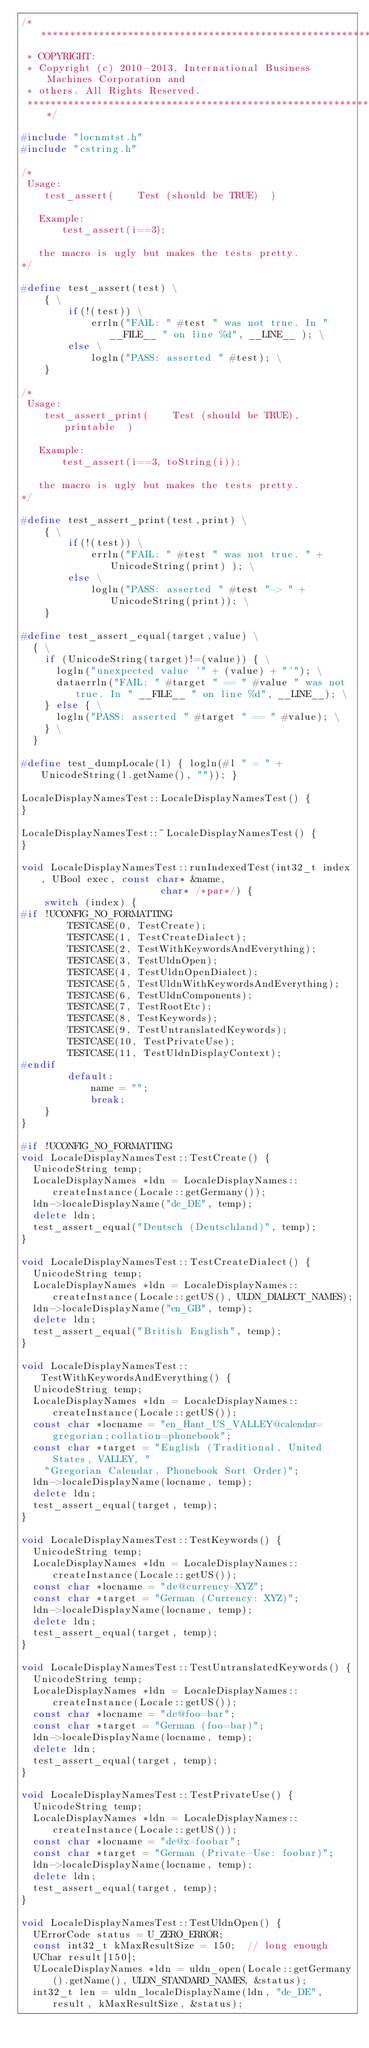Convert code to text. <code><loc_0><loc_0><loc_500><loc_500><_C++_>/*********************************************************************
 * COPYRIGHT:
 * Copyright (c) 2010-2013, International Business Machines Corporation and
 * others. All Rights Reserved.
 *********************************************************************/

#include "locnmtst.h"
#include "cstring.h"

/*
 Usage:
    test_assert(    Test (should be TRUE)  )

   Example:
       test_assert(i==3);

   the macro is ugly but makes the tests pretty.
*/

#define test_assert(test) \
    { \
        if(!(test)) \
            errln("FAIL: " #test " was not true. In " __FILE__ " on line %d", __LINE__ ); \
        else \
            logln("PASS: asserted " #test); \
    }

/*
 Usage:
    test_assert_print(    Test (should be TRUE),  printable  )

   Example:
       test_assert(i==3, toString(i));

   the macro is ugly but makes the tests pretty.
*/

#define test_assert_print(test,print) \
    { \
        if(!(test)) \
            errln("FAIL: " #test " was not true. " + UnicodeString(print) ); \
        else \
            logln("PASS: asserted " #test "-> " + UnicodeString(print)); \
    }

#define test_assert_equal(target,value) \
  { \
    if (UnicodeString(target)!=(value)) { \
      logln("unexpected value '" + (value) + "'"); \
      dataerrln("FAIL: " #target " == " #value " was not true. In " __FILE__ " on line %d", __LINE__); \
    } else { \
      logln("PASS: asserted " #target " == " #value); \
    } \
  }

#define test_dumpLocale(l) { logln(#l " = " + UnicodeString(l.getName(), "")); }

LocaleDisplayNamesTest::LocaleDisplayNamesTest() {
}

LocaleDisplayNamesTest::~LocaleDisplayNamesTest() {
}

void LocaleDisplayNamesTest::runIndexedTest(int32_t index, UBool exec, const char* &name, 
                        char* /*par*/) {
    switch (index) {
#if !UCONFIG_NO_FORMATTING
        TESTCASE(0, TestCreate);
        TESTCASE(1, TestCreateDialect);
        TESTCASE(2, TestWithKeywordsAndEverything);
        TESTCASE(3, TestUldnOpen);
        TESTCASE(4, TestUldnOpenDialect);
        TESTCASE(5, TestUldnWithKeywordsAndEverything);
        TESTCASE(6, TestUldnComponents);
        TESTCASE(7, TestRootEtc);
        TESTCASE(8, TestKeywords);
        TESTCASE(9, TestUntranslatedKeywords);
        TESTCASE(10, TestPrivateUse);
        TESTCASE(11, TestUldnDisplayContext);
#endif
        default:
            name = "";
            break;
    }
}

#if !UCONFIG_NO_FORMATTING
void LocaleDisplayNamesTest::TestCreate() {
  UnicodeString temp;
  LocaleDisplayNames *ldn = LocaleDisplayNames::createInstance(Locale::getGermany());
  ldn->localeDisplayName("de_DE", temp);
  delete ldn;
  test_assert_equal("Deutsch (Deutschland)", temp);
}

void LocaleDisplayNamesTest::TestCreateDialect() {
  UnicodeString temp;
  LocaleDisplayNames *ldn = LocaleDisplayNames::createInstance(Locale::getUS(), ULDN_DIALECT_NAMES);
  ldn->localeDisplayName("en_GB", temp);
  delete ldn;
  test_assert_equal("British English", temp);
}

void LocaleDisplayNamesTest::TestWithKeywordsAndEverything() {
  UnicodeString temp;
  LocaleDisplayNames *ldn = LocaleDisplayNames::createInstance(Locale::getUS());
  const char *locname = "en_Hant_US_VALLEY@calendar=gregorian;collation=phonebook";
  const char *target = "English (Traditional, United States, VALLEY, "
    "Gregorian Calendar, Phonebook Sort Order)";
  ldn->localeDisplayName(locname, temp);
  delete ldn;
  test_assert_equal(target, temp);
}

void LocaleDisplayNamesTest::TestKeywords() {
  UnicodeString temp;
  LocaleDisplayNames *ldn = LocaleDisplayNames::createInstance(Locale::getUS());
  const char *locname = "de@currency=XYZ";
  const char *target = "German (Currency: XYZ)";
  ldn->localeDisplayName(locname, temp);
  delete ldn;
  test_assert_equal(target, temp);
}

void LocaleDisplayNamesTest::TestUntranslatedKeywords() {
  UnicodeString temp;
  LocaleDisplayNames *ldn = LocaleDisplayNames::createInstance(Locale::getUS());
  const char *locname = "de@foo=bar";
  const char *target = "German (foo=bar)";
  ldn->localeDisplayName(locname, temp);
  delete ldn;
  test_assert_equal(target, temp);
}

void LocaleDisplayNamesTest::TestPrivateUse() {
  UnicodeString temp;
  LocaleDisplayNames *ldn = LocaleDisplayNames::createInstance(Locale::getUS());
  const char *locname = "de@x=foobar";
  const char *target = "German (Private-Use: foobar)";
  ldn->localeDisplayName(locname, temp);
  delete ldn;
  test_assert_equal(target, temp);
}

void LocaleDisplayNamesTest::TestUldnOpen() {
  UErrorCode status = U_ZERO_ERROR;
  const int32_t kMaxResultSize = 150;  // long enough
  UChar result[150];
  ULocaleDisplayNames *ldn = uldn_open(Locale::getGermany().getName(), ULDN_STANDARD_NAMES, &status);
  int32_t len = uldn_localeDisplayName(ldn, "de_DE", result, kMaxResultSize, &status);</code> 